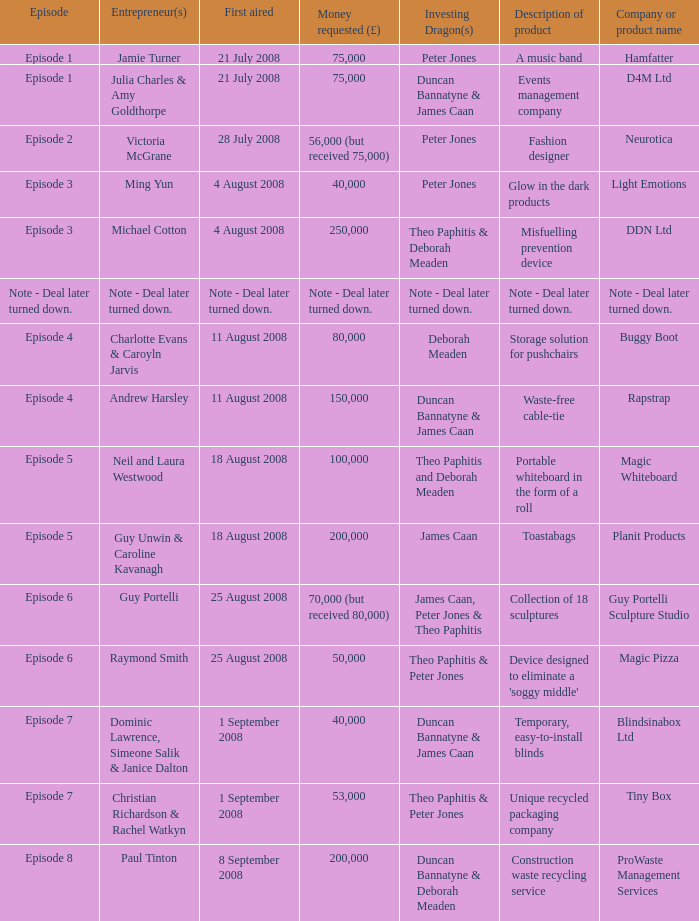Parse the table in full. {'header': ['Episode', 'Entrepreneur(s)', 'First aired', 'Money requested (£)', 'Investing Dragon(s)', 'Description of product', 'Company or product name'], 'rows': [['Episode 1', 'Jamie Turner', '21 July 2008', '75,000', 'Peter Jones', 'A music band', 'Hamfatter'], ['Episode 1', 'Julia Charles & Amy Goldthorpe', '21 July 2008', '75,000', 'Duncan Bannatyne & James Caan', 'Events management company', 'D4M Ltd'], ['Episode 2', 'Victoria McGrane', '28 July 2008', '56,000 (but received 75,000)', 'Peter Jones', 'Fashion designer', 'Neurotica'], ['Episode 3', 'Ming Yun', '4 August 2008', '40,000', 'Peter Jones', 'Glow in the dark products', 'Light Emotions'], ['Episode 3', 'Michael Cotton', '4 August 2008', '250,000', 'Theo Paphitis & Deborah Meaden', 'Misfuelling prevention device', 'DDN Ltd'], ['Note - Deal later turned down.', 'Note - Deal later turned down.', 'Note - Deal later turned down.', 'Note - Deal later turned down.', 'Note - Deal later turned down.', 'Note - Deal later turned down.', 'Note - Deal later turned down.'], ['Episode 4', 'Charlotte Evans & Caroyln Jarvis', '11 August 2008', '80,000', 'Deborah Meaden', 'Storage solution for pushchairs', 'Buggy Boot'], ['Episode 4', 'Andrew Harsley', '11 August 2008', '150,000', 'Duncan Bannatyne & James Caan', 'Waste-free cable-tie', 'Rapstrap'], ['Episode 5', 'Neil and Laura Westwood', '18 August 2008', '100,000', 'Theo Paphitis and Deborah Meaden', 'Portable whiteboard in the form of a roll', 'Magic Whiteboard'], ['Episode 5', 'Guy Unwin & Caroline Kavanagh', '18 August 2008', '200,000', 'James Caan', 'Toastabags', 'Planit Products'], ['Episode 6', 'Guy Portelli', '25 August 2008', '70,000 (but received 80,000)', 'James Caan, Peter Jones & Theo Paphitis', 'Collection of 18 sculptures', 'Guy Portelli Sculpture Studio'], ['Episode 6', 'Raymond Smith', '25 August 2008', '50,000', 'Theo Paphitis & Peter Jones', "Device designed to eliminate a 'soggy middle'", 'Magic Pizza'], ['Episode 7', 'Dominic Lawrence, Simeone Salik & Janice Dalton', '1 September 2008', '40,000', 'Duncan Bannatyne & James Caan', 'Temporary, easy-to-install blinds', 'Blindsinabox Ltd'], ['Episode 7', 'Christian Richardson & Rachel Watkyn', '1 September 2008', '53,000', 'Theo Paphitis & Peter Jones', 'Unique recycled packaging company', 'Tiny Box'], ['Episode 8', 'Paul Tinton', '8 September 2008', '200,000', 'Duncan Bannatyne & Deborah Meaden', 'Construction waste recycling service', 'ProWaste Management Services']]} When did episode 6 first air with entrepreneur Guy Portelli? 25 August 2008. 